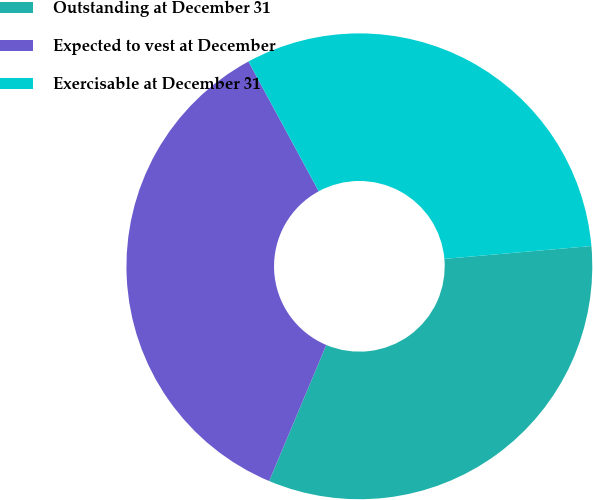Convert chart to OTSL. <chart><loc_0><loc_0><loc_500><loc_500><pie_chart><fcel>Outstanding at December 31<fcel>Expected to vest at December<fcel>Exercisable at December 31<nl><fcel>32.72%<fcel>35.77%<fcel>31.51%<nl></chart> 